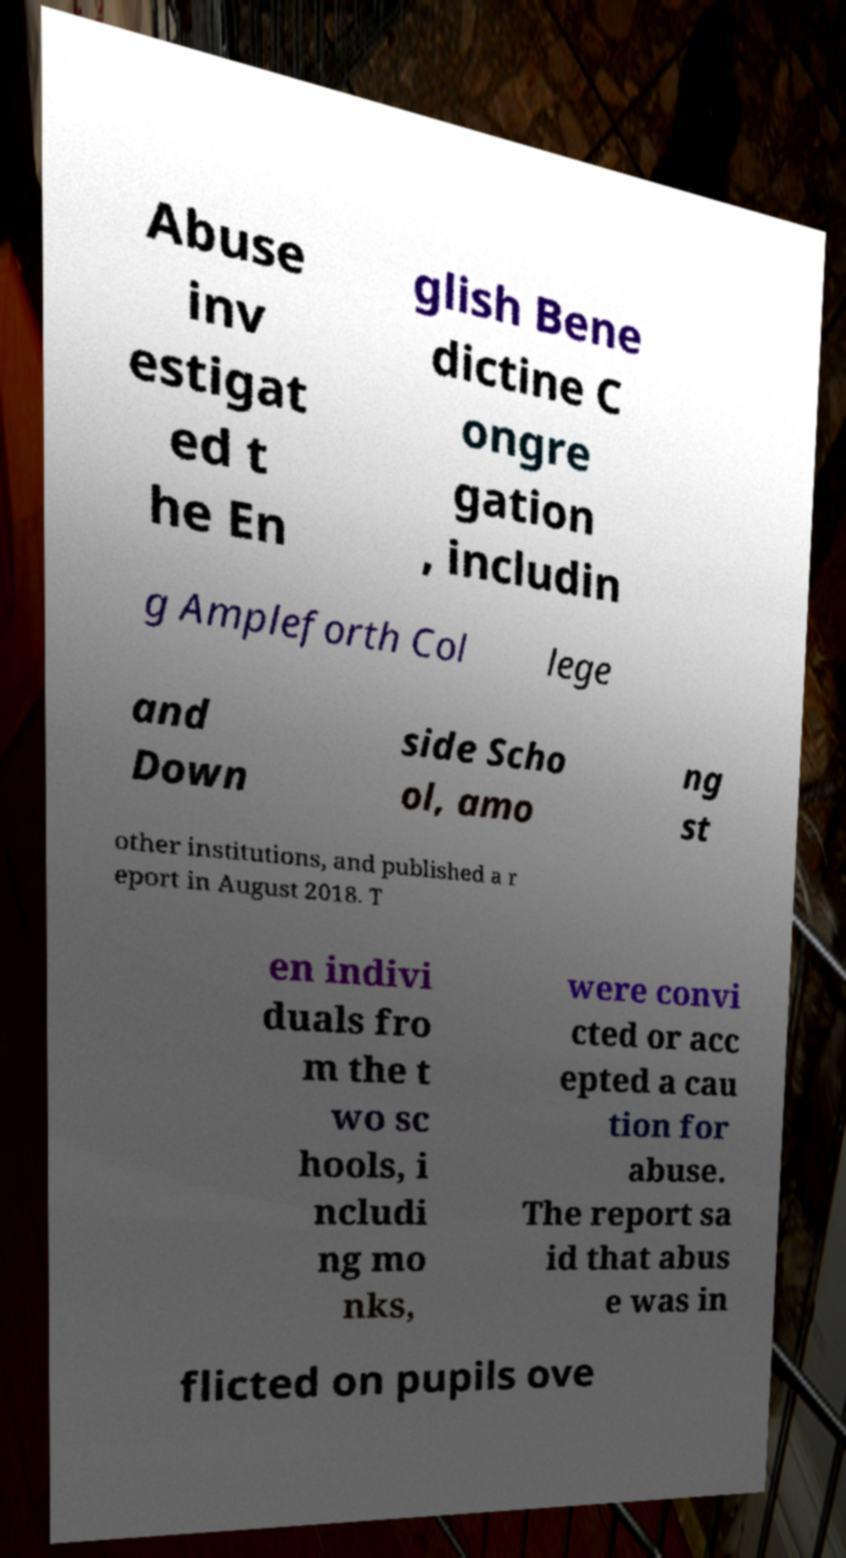Can you accurately transcribe the text from the provided image for me? Abuse inv estigat ed t he En glish Bene dictine C ongre gation , includin g Ampleforth Col lege and Down side Scho ol, amo ng st other institutions, and published a r eport in August 2018. T en indivi duals fro m the t wo sc hools, i ncludi ng mo nks, were convi cted or acc epted a cau tion for abuse. The report sa id that abus e was in flicted on pupils ove 